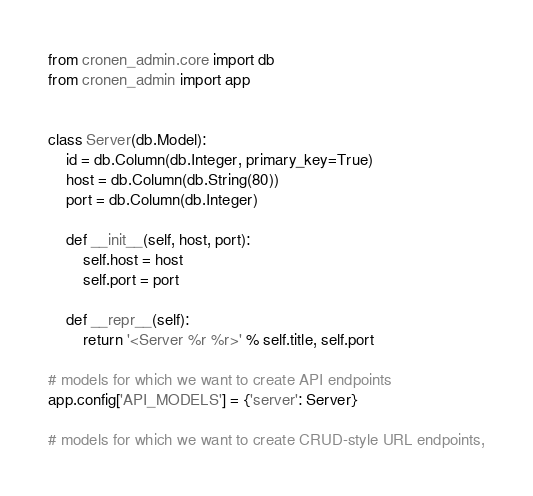<code> <loc_0><loc_0><loc_500><loc_500><_Python_>from cronen_admin.core import db
from cronen_admin import app


class Server(db.Model):
    id = db.Column(db.Integer, primary_key=True)
    host = db.Column(db.String(80))
    port = db.Column(db.Integer)

    def __init__(self, host, port):
        self.host = host
        self.port = port

    def __repr__(self):
        return '<Server %r %r>' % self.title, self.port

# models for which we want to create API endpoints
app.config['API_MODELS'] = {'server': Server}

# models for which we want to create CRUD-style URL endpoints,</code> 